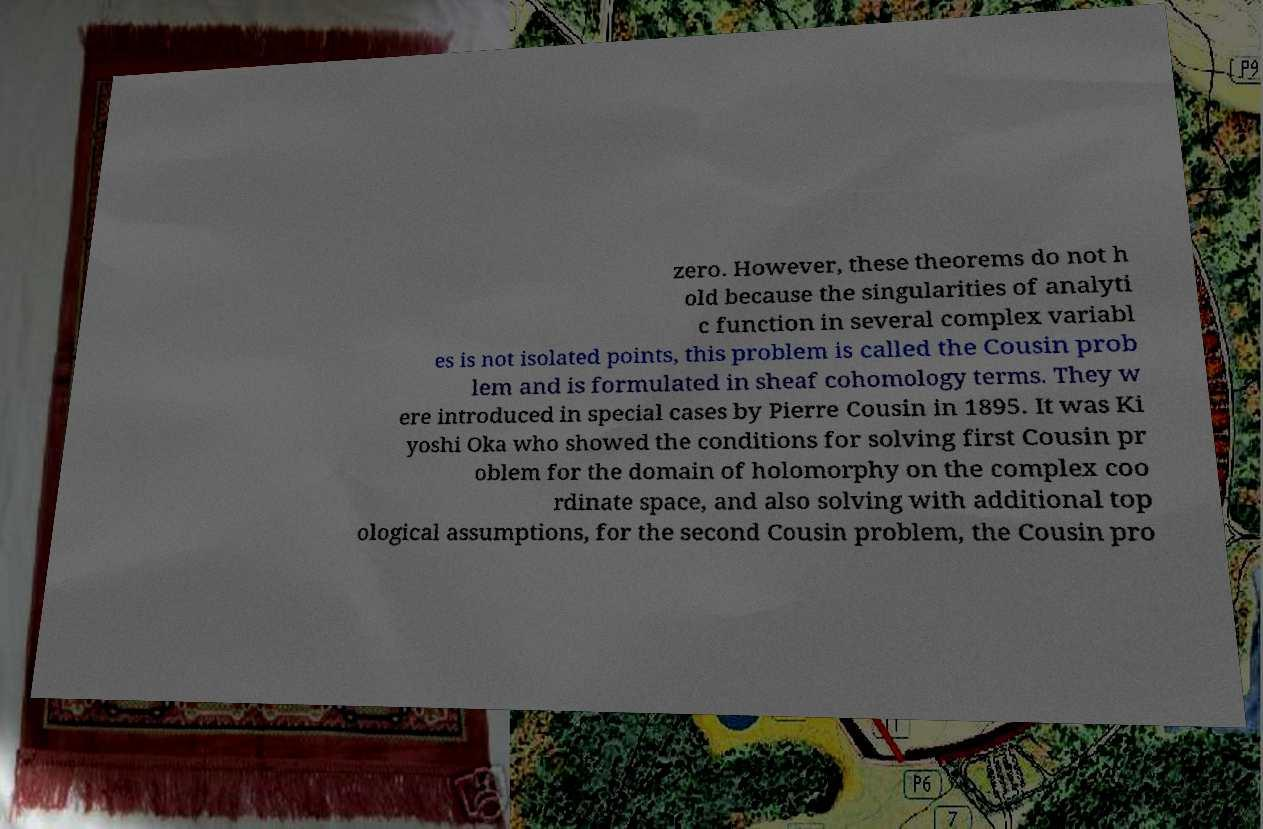There's text embedded in this image that I need extracted. Can you transcribe it verbatim? zero. However, these theorems do not h old because the singularities of analyti c function in several complex variabl es is not isolated points, this problem is called the Cousin prob lem and is formulated in sheaf cohomology terms. They w ere introduced in special cases by Pierre Cousin in 1895. It was Ki yoshi Oka who showed the conditions for solving first Cousin pr oblem for the domain of holomorphy on the complex coo rdinate space, and also solving with additional top ological assumptions, for the second Cousin problem, the Cousin pro 